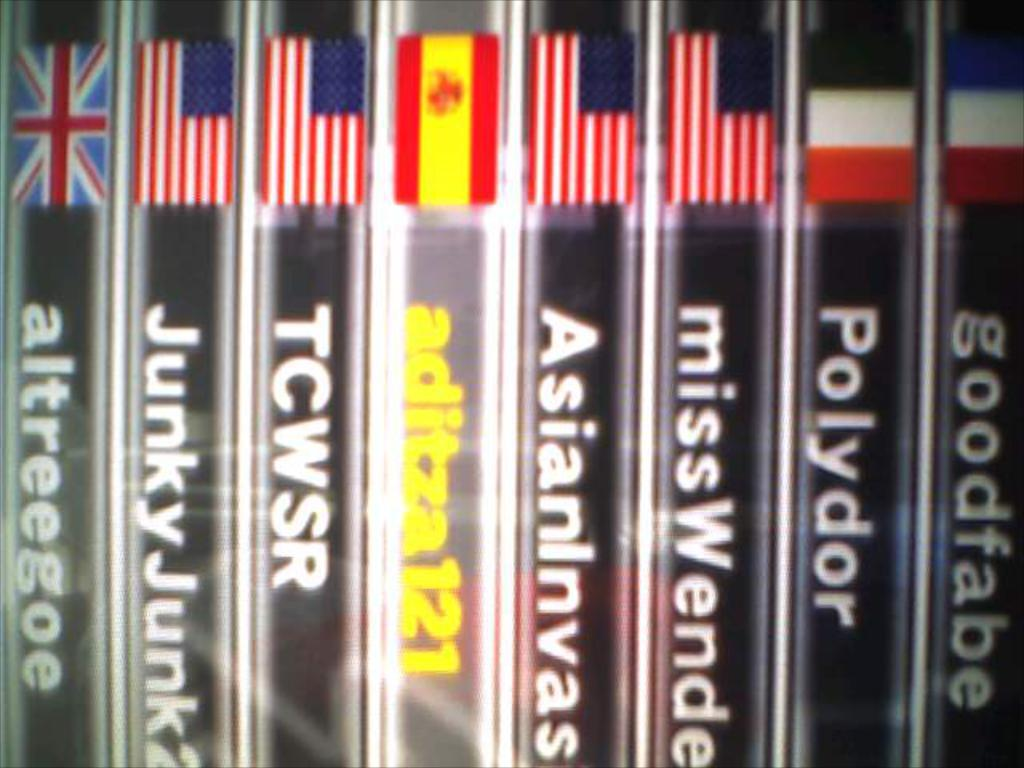<image>
Offer a succinct explanation of the picture presented. A stack of cases that read goodfabe, Polydor, missWende 